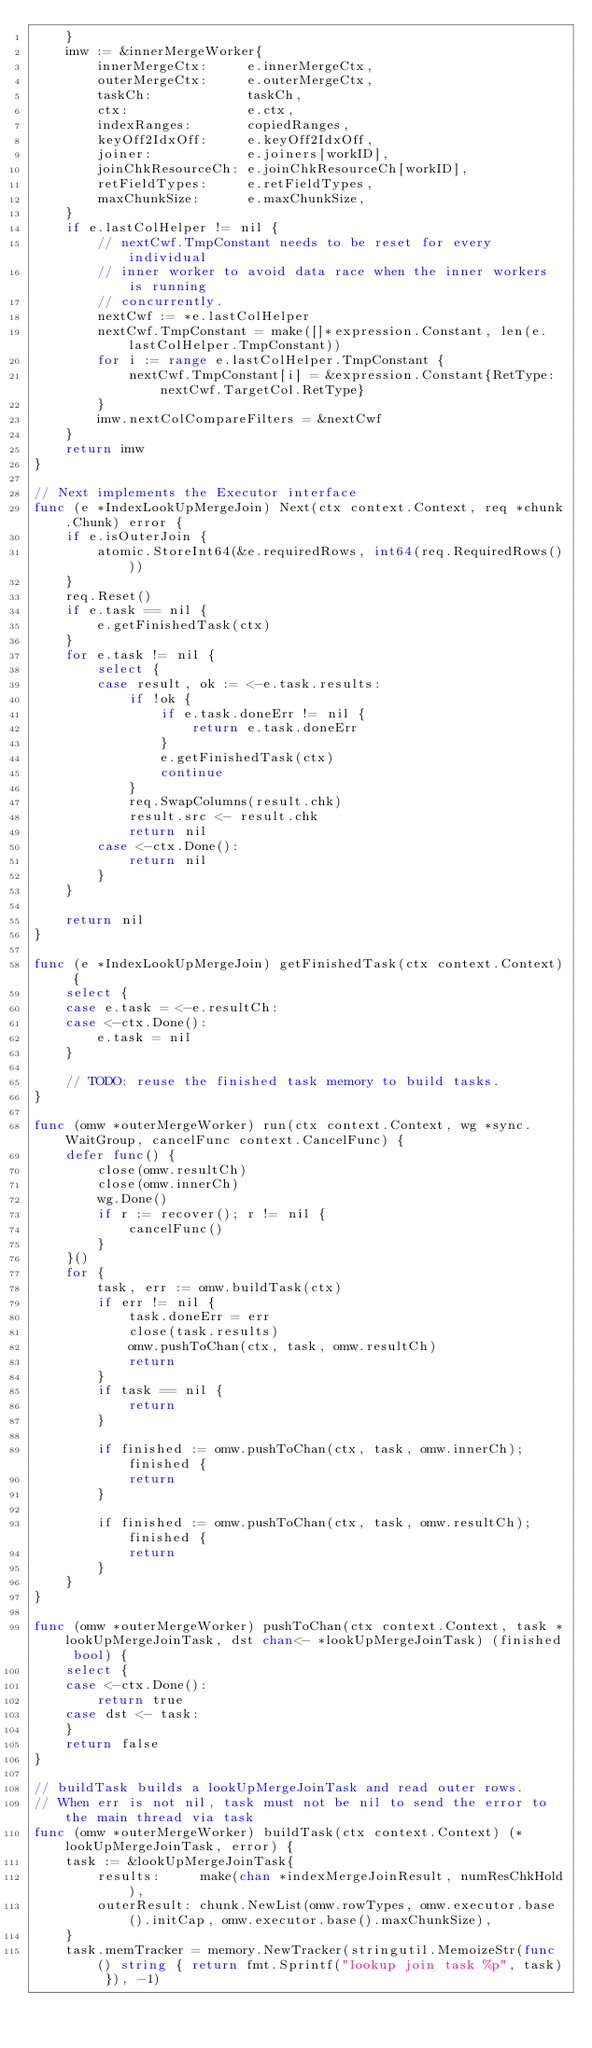Convert code to text. <code><loc_0><loc_0><loc_500><loc_500><_Go_>	}
	imw := &innerMergeWorker{
		innerMergeCtx:     e.innerMergeCtx,
		outerMergeCtx:     e.outerMergeCtx,
		taskCh:            taskCh,
		ctx:               e.ctx,
		indexRanges:       copiedRanges,
		keyOff2IdxOff:     e.keyOff2IdxOff,
		joiner:            e.joiners[workID],
		joinChkResourceCh: e.joinChkResourceCh[workID],
		retFieldTypes:     e.retFieldTypes,
		maxChunkSize:      e.maxChunkSize,
	}
	if e.lastColHelper != nil {
		// nextCwf.TmpConstant needs to be reset for every individual
		// inner worker to avoid data race when the inner workers is running
		// concurrently.
		nextCwf := *e.lastColHelper
		nextCwf.TmpConstant = make([]*expression.Constant, len(e.lastColHelper.TmpConstant))
		for i := range e.lastColHelper.TmpConstant {
			nextCwf.TmpConstant[i] = &expression.Constant{RetType: nextCwf.TargetCol.RetType}
		}
		imw.nextColCompareFilters = &nextCwf
	}
	return imw
}

// Next implements the Executor interface
func (e *IndexLookUpMergeJoin) Next(ctx context.Context, req *chunk.Chunk) error {
	if e.isOuterJoin {
		atomic.StoreInt64(&e.requiredRows, int64(req.RequiredRows()))
	}
	req.Reset()
	if e.task == nil {
		e.getFinishedTask(ctx)
	}
	for e.task != nil {
		select {
		case result, ok := <-e.task.results:
			if !ok {
				if e.task.doneErr != nil {
					return e.task.doneErr
				}
				e.getFinishedTask(ctx)
				continue
			}
			req.SwapColumns(result.chk)
			result.src <- result.chk
			return nil
		case <-ctx.Done():
			return nil
		}
	}

	return nil
}

func (e *IndexLookUpMergeJoin) getFinishedTask(ctx context.Context) {
	select {
	case e.task = <-e.resultCh:
	case <-ctx.Done():
		e.task = nil
	}

	// TODO: reuse the finished task memory to build tasks.
}

func (omw *outerMergeWorker) run(ctx context.Context, wg *sync.WaitGroup, cancelFunc context.CancelFunc) {
	defer func() {
		close(omw.resultCh)
		close(omw.innerCh)
		wg.Done()
		if r := recover(); r != nil {
			cancelFunc()
		}
	}()
	for {
		task, err := omw.buildTask(ctx)
		if err != nil {
			task.doneErr = err
			close(task.results)
			omw.pushToChan(ctx, task, omw.resultCh)
			return
		}
		if task == nil {
			return
		}

		if finished := omw.pushToChan(ctx, task, omw.innerCh); finished {
			return
		}

		if finished := omw.pushToChan(ctx, task, omw.resultCh); finished {
			return
		}
	}
}

func (omw *outerMergeWorker) pushToChan(ctx context.Context, task *lookUpMergeJoinTask, dst chan<- *lookUpMergeJoinTask) (finished bool) {
	select {
	case <-ctx.Done():
		return true
	case dst <- task:
	}
	return false
}

// buildTask builds a lookUpMergeJoinTask and read outer rows.
// When err is not nil, task must not be nil to send the error to the main thread via task
func (omw *outerMergeWorker) buildTask(ctx context.Context) (*lookUpMergeJoinTask, error) {
	task := &lookUpMergeJoinTask{
		results:     make(chan *indexMergeJoinResult, numResChkHold),
		outerResult: chunk.NewList(omw.rowTypes, omw.executor.base().initCap, omw.executor.base().maxChunkSize),
	}
	task.memTracker = memory.NewTracker(stringutil.MemoizeStr(func() string { return fmt.Sprintf("lookup join task %p", task) }), -1)</code> 